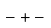Convert formula to latex. <formula><loc_0><loc_0><loc_500><loc_500>- + -</formula> 